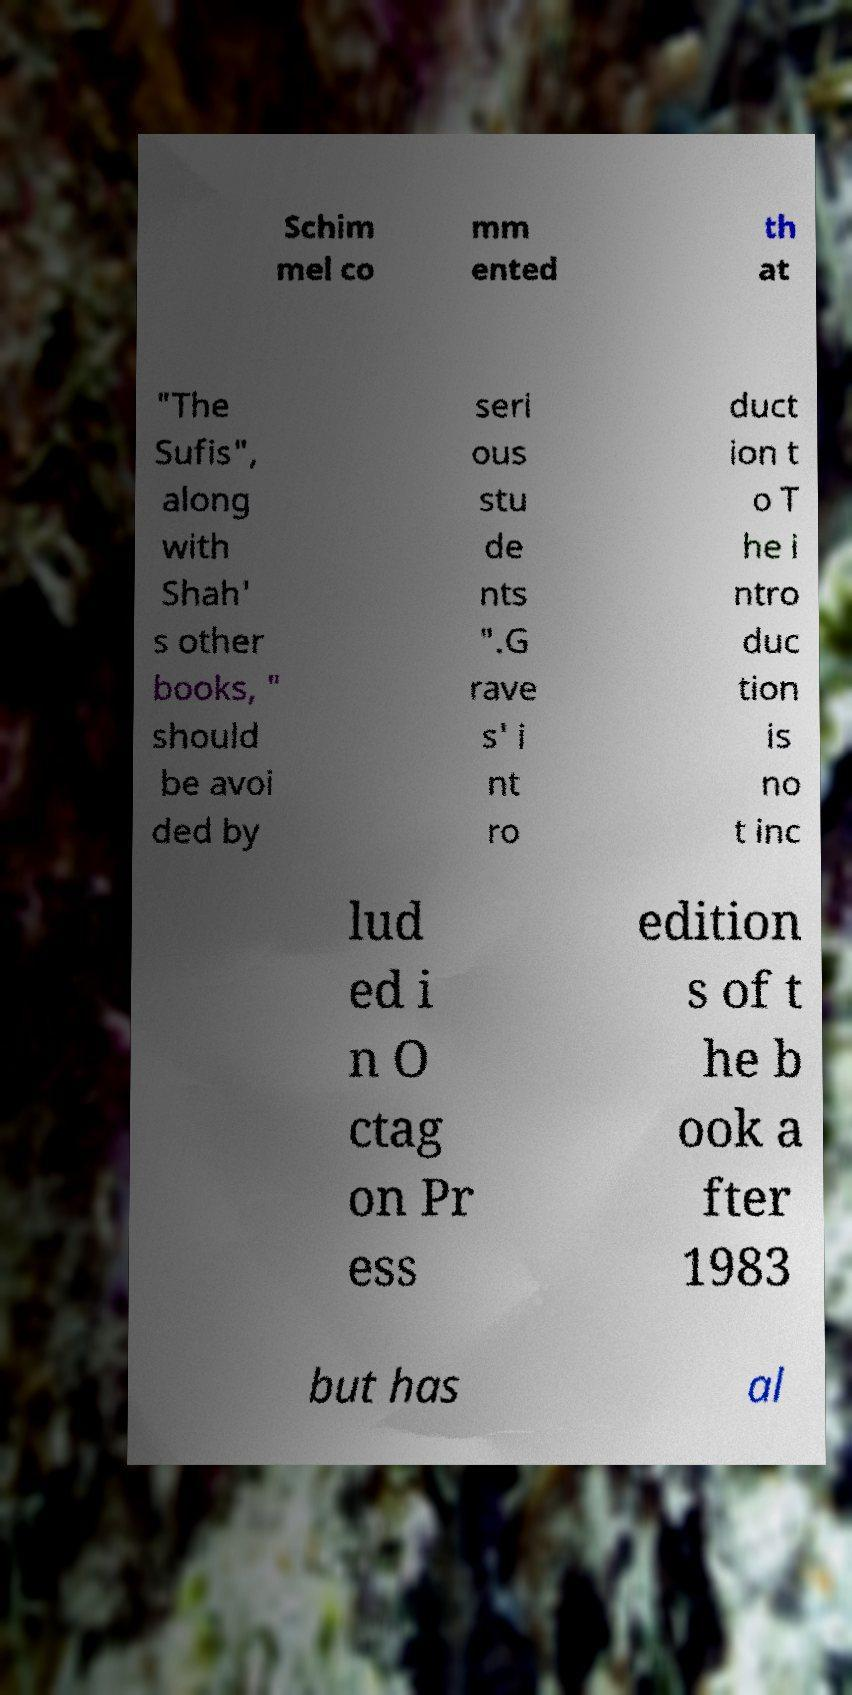There's text embedded in this image that I need extracted. Can you transcribe it verbatim? Schim mel co mm ented th at "The Sufis", along with Shah' s other books, " should be avoi ded by seri ous stu de nts ".G rave s' i nt ro duct ion t o T he i ntro duc tion is no t inc lud ed i n O ctag on Pr ess edition s of t he b ook a fter 1983 but has al 